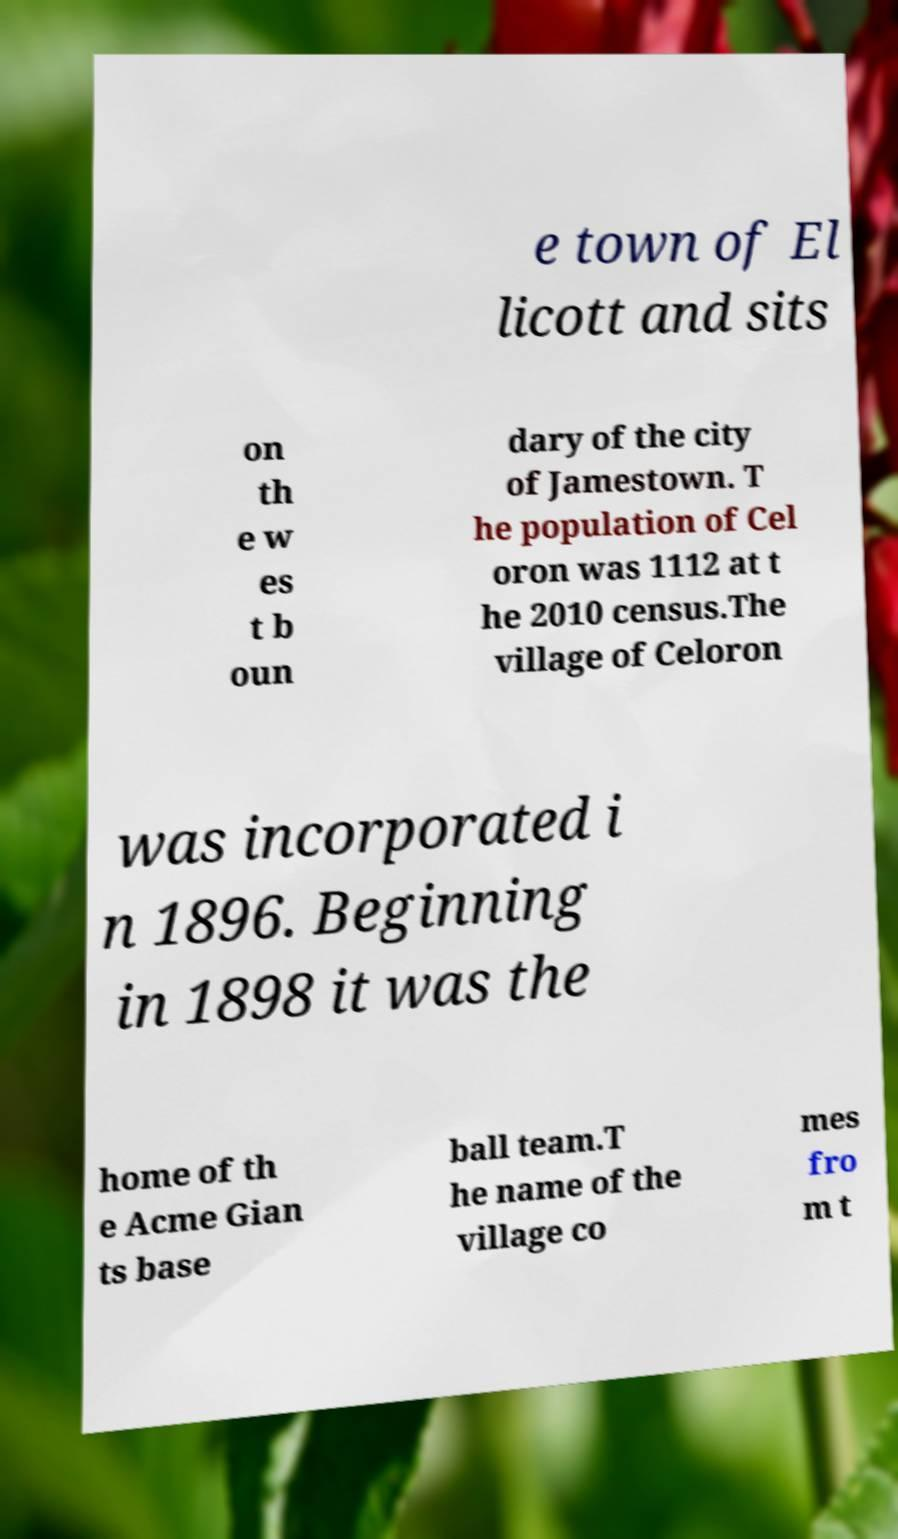Can you read and provide the text displayed in the image?This photo seems to have some interesting text. Can you extract and type it out for me? e town of El licott and sits on th e w es t b oun dary of the city of Jamestown. T he population of Cel oron was 1112 at t he 2010 census.The village of Celoron was incorporated i n 1896. Beginning in 1898 it was the home of th e Acme Gian ts base ball team.T he name of the village co mes fro m t 